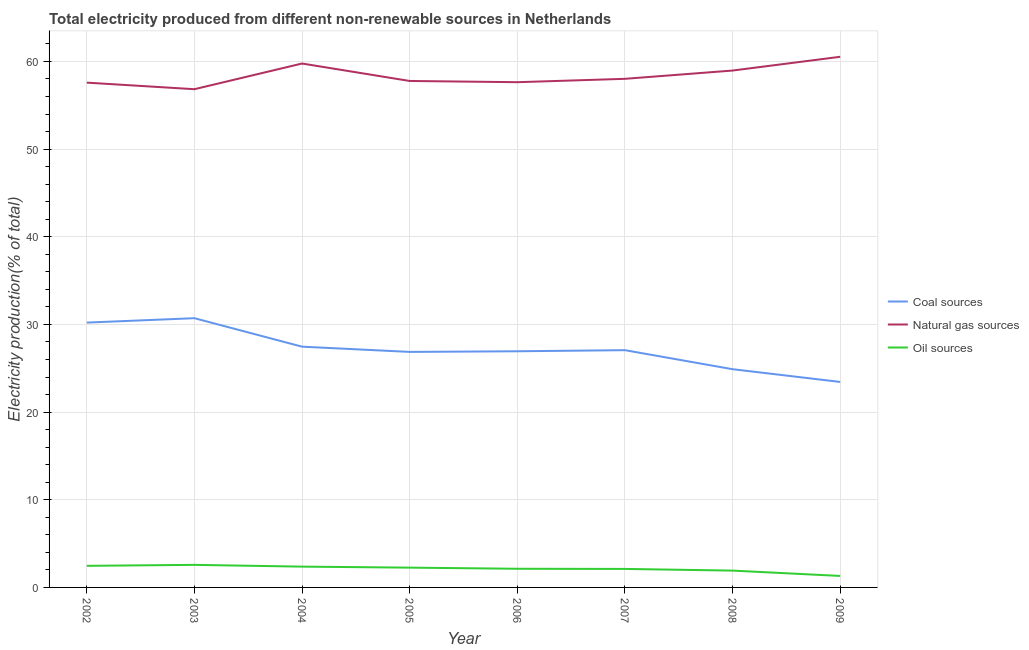How many different coloured lines are there?
Offer a very short reply. 3. What is the percentage of electricity produced by natural gas in 2005?
Your response must be concise. 57.77. Across all years, what is the maximum percentage of electricity produced by coal?
Your answer should be very brief. 30.71. Across all years, what is the minimum percentage of electricity produced by natural gas?
Provide a succinct answer. 56.83. In which year was the percentage of electricity produced by oil sources maximum?
Your answer should be very brief. 2003. What is the total percentage of electricity produced by natural gas in the graph?
Your response must be concise. 467.1. What is the difference between the percentage of electricity produced by natural gas in 2003 and that in 2007?
Keep it short and to the point. -1.18. What is the difference between the percentage of electricity produced by coal in 2006 and the percentage of electricity produced by natural gas in 2003?
Offer a terse response. -29.9. What is the average percentage of electricity produced by coal per year?
Your answer should be compact. 27.2. In the year 2009, what is the difference between the percentage of electricity produced by oil sources and percentage of electricity produced by natural gas?
Offer a very short reply. -59.22. In how many years, is the percentage of electricity produced by oil sources greater than 16 %?
Ensure brevity in your answer.  0. What is the ratio of the percentage of electricity produced by oil sources in 2004 to that in 2005?
Your answer should be very brief. 1.05. Is the percentage of electricity produced by oil sources in 2002 less than that in 2006?
Give a very brief answer. No. What is the difference between the highest and the second highest percentage of electricity produced by coal?
Keep it short and to the point. 0.5. What is the difference between the highest and the lowest percentage of electricity produced by coal?
Ensure brevity in your answer.  7.27. Is it the case that in every year, the sum of the percentage of electricity produced by coal and percentage of electricity produced by natural gas is greater than the percentage of electricity produced by oil sources?
Your response must be concise. Yes. Does the percentage of electricity produced by natural gas monotonically increase over the years?
Your answer should be compact. No. How many lines are there?
Make the answer very short. 3. Does the graph contain grids?
Keep it short and to the point. Yes. How are the legend labels stacked?
Your answer should be compact. Vertical. What is the title of the graph?
Give a very brief answer. Total electricity produced from different non-renewable sources in Netherlands. Does "Spain" appear as one of the legend labels in the graph?
Make the answer very short. No. What is the Electricity production(% of total) in Coal sources in 2002?
Your answer should be very brief. 30.21. What is the Electricity production(% of total) of Natural gas sources in 2002?
Your answer should be compact. 57.58. What is the Electricity production(% of total) in Oil sources in 2002?
Your response must be concise. 2.46. What is the Electricity production(% of total) in Coal sources in 2003?
Ensure brevity in your answer.  30.71. What is the Electricity production(% of total) in Natural gas sources in 2003?
Provide a short and direct response. 56.83. What is the Electricity production(% of total) in Oil sources in 2003?
Provide a short and direct response. 2.57. What is the Electricity production(% of total) of Coal sources in 2004?
Keep it short and to the point. 27.46. What is the Electricity production(% of total) in Natural gas sources in 2004?
Your answer should be very brief. 59.76. What is the Electricity production(% of total) of Oil sources in 2004?
Give a very brief answer. 2.37. What is the Electricity production(% of total) in Coal sources in 2005?
Ensure brevity in your answer.  26.87. What is the Electricity production(% of total) of Natural gas sources in 2005?
Give a very brief answer. 57.77. What is the Electricity production(% of total) of Oil sources in 2005?
Keep it short and to the point. 2.26. What is the Electricity production(% of total) in Coal sources in 2006?
Offer a terse response. 26.94. What is the Electricity production(% of total) in Natural gas sources in 2006?
Ensure brevity in your answer.  57.63. What is the Electricity production(% of total) of Oil sources in 2006?
Keep it short and to the point. 2.13. What is the Electricity production(% of total) in Coal sources in 2007?
Keep it short and to the point. 27.06. What is the Electricity production(% of total) in Natural gas sources in 2007?
Your response must be concise. 58.02. What is the Electricity production(% of total) in Oil sources in 2007?
Your response must be concise. 2.11. What is the Electricity production(% of total) of Coal sources in 2008?
Your answer should be very brief. 24.89. What is the Electricity production(% of total) in Natural gas sources in 2008?
Make the answer very short. 58.96. What is the Electricity production(% of total) in Oil sources in 2008?
Keep it short and to the point. 1.92. What is the Electricity production(% of total) in Coal sources in 2009?
Ensure brevity in your answer.  23.44. What is the Electricity production(% of total) in Natural gas sources in 2009?
Your response must be concise. 60.53. What is the Electricity production(% of total) of Oil sources in 2009?
Offer a very short reply. 1.31. Across all years, what is the maximum Electricity production(% of total) in Coal sources?
Provide a succinct answer. 30.71. Across all years, what is the maximum Electricity production(% of total) in Natural gas sources?
Your response must be concise. 60.53. Across all years, what is the maximum Electricity production(% of total) of Oil sources?
Provide a succinct answer. 2.57. Across all years, what is the minimum Electricity production(% of total) in Coal sources?
Keep it short and to the point. 23.44. Across all years, what is the minimum Electricity production(% of total) of Natural gas sources?
Your answer should be very brief. 56.83. Across all years, what is the minimum Electricity production(% of total) in Oil sources?
Your answer should be very brief. 1.31. What is the total Electricity production(% of total) of Coal sources in the graph?
Make the answer very short. 217.59. What is the total Electricity production(% of total) in Natural gas sources in the graph?
Your answer should be compact. 467.1. What is the total Electricity production(% of total) of Oil sources in the graph?
Provide a short and direct response. 17.14. What is the difference between the Electricity production(% of total) in Coal sources in 2002 and that in 2003?
Give a very brief answer. -0.5. What is the difference between the Electricity production(% of total) of Natural gas sources in 2002 and that in 2003?
Offer a very short reply. 0.75. What is the difference between the Electricity production(% of total) in Oil sources in 2002 and that in 2003?
Keep it short and to the point. -0.11. What is the difference between the Electricity production(% of total) in Coal sources in 2002 and that in 2004?
Make the answer very short. 2.75. What is the difference between the Electricity production(% of total) of Natural gas sources in 2002 and that in 2004?
Your answer should be compact. -2.18. What is the difference between the Electricity production(% of total) of Oil sources in 2002 and that in 2004?
Ensure brevity in your answer.  0.09. What is the difference between the Electricity production(% of total) in Coal sources in 2002 and that in 2005?
Your answer should be compact. 3.34. What is the difference between the Electricity production(% of total) in Natural gas sources in 2002 and that in 2005?
Your answer should be compact. -0.19. What is the difference between the Electricity production(% of total) in Oil sources in 2002 and that in 2005?
Offer a terse response. 0.21. What is the difference between the Electricity production(% of total) in Coal sources in 2002 and that in 2006?
Keep it short and to the point. 3.27. What is the difference between the Electricity production(% of total) of Natural gas sources in 2002 and that in 2006?
Ensure brevity in your answer.  -0.05. What is the difference between the Electricity production(% of total) in Oil sources in 2002 and that in 2006?
Give a very brief answer. 0.33. What is the difference between the Electricity production(% of total) in Coal sources in 2002 and that in 2007?
Your answer should be very brief. 3.15. What is the difference between the Electricity production(% of total) of Natural gas sources in 2002 and that in 2007?
Make the answer very short. -0.44. What is the difference between the Electricity production(% of total) of Oil sources in 2002 and that in 2007?
Keep it short and to the point. 0.35. What is the difference between the Electricity production(% of total) of Coal sources in 2002 and that in 2008?
Your answer should be very brief. 5.32. What is the difference between the Electricity production(% of total) of Natural gas sources in 2002 and that in 2008?
Your response must be concise. -1.38. What is the difference between the Electricity production(% of total) in Oil sources in 2002 and that in 2008?
Provide a short and direct response. 0.54. What is the difference between the Electricity production(% of total) in Coal sources in 2002 and that in 2009?
Your answer should be very brief. 6.77. What is the difference between the Electricity production(% of total) in Natural gas sources in 2002 and that in 2009?
Make the answer very short. -2.95. What is the difference between the Electricity production(% of total) of Oil sources in 2002 and that in 2009?
Provide a short and direct response. 1.15. What is the difference between the Electricity production(% of total) in Coal sources in 2003 and that in 2004?
Offer a terse response. 3.25. What is the difference between the Electricity production(% of total) of Natural gas sources in 2003 and that in 2004?
Provide a short and direct response. -2.93. What is the difference between the Electricity production(% of total) of Oil sources in 2003 and that in 2004?
Your answer should be very brief. 0.2. What is the difference between the Electricity production(% of total) in Coal sources in 2003 and that in 2005?
Your answer should be compact. 3.84. What is the difference between the Electricity production(% of total) of Natural gas sources in 2003 and that in 2005?
Offer a very short reply. -0.94. What is the difference between the Electricity production(% of total) in Oil sources in 2003 and that in 2005?
Keep it short and to the point. 0.32. What is the difference between the Electricity production(% of total) of Coal sources in 2003 and that in 2006?
Give a very brief answer. 3.77. What is the difference between the Electricity production(% of total) in Natural gas sources in 2003 and that in 2006?
Your answer should be compact. -0.8. What is the difference between the Electricity production(% of total) in Oil sources in 2003 and that in 2006?
Provide a succinct answer. 0.45. What is the difference between the Electricity production(% of total) of Coal sources in 2003 and that in 2007?
Make the answer very short. 3.65. What is the difference between the Electricity production(% of total) of Natural gas sources in 2003 and that in 2007?
Offer a terse response. -1.18. What is the difference between the Electricity production(% of total) of Oil sources in 2003 and that in 2007?
Offer a very short reply. 0.46. What is the difference between the Electricity production(% of total) in Coal sources in 2003 and that in 2008?
Offer a very short reply. 5.82. What is the difference between the Electricity production(% of total) in Natural gas sources in 2003 and that in 2008?
Provide a succinct answer. -2.13. What is the difference between the Electricity production(% of total) of Oil sources in 2003 and that in 2008?
Give a very brief answer. 0.66. What is the difference between the Electricity production(% of total) in Coal sources in 2003 and that in 2009?
Keep it short and to the point. 7.27. What is the difference between the Electricity production(% of total) of Natural gas sources in 2003 and that in 2009?
Your answer should be very brief. -3.7. What is the difference between the Electricity production(% of total) in Oil sources in 2003 and that in 2009?
Provide a short and direct response. 1.26. What is the difference between the Electricity production(% of total) in Coal sources in 2004 and that in 2005?
Your answer should be compact. 0.6. What is the difference between the Electricity production(% of total) in Natural gas sources in 2004 and that in 2005?
Offer a very short reply. 1.99. What is the difference between the Electricity production(% of total) of Oil sources in 2004 and that in 2005?
Your response must be concise. 0.12. What is the difference between the Electricity production(% of total) of Coal sources in 2004 and that in 2006?
Provide a succinct answer. 0.52. What is the difference between the Electricity production(% of total) in Natural gas sources in 2004 and that in 2006?
Your response must be concise. 2.13. What is the difference between the Electricity production(% of total) of Oil sources in 2004 and that in 2006?
Offer a very short reply. 0.24. What is the difference between the Electricity production(% of total) of Coal sources in 2004 and that in 2007?
Make the answer very short. 0.4. What is the difference between the Electricity production(% of total) in Natural gas sources in 2004 and that in 2007?
Your response must be concise. 1.74. What is the difference between the Electricity production(% of total) of Oil sources in 2004 and that in 2007?
Provide a short and direct response. 0.26. What is the difference between the Electricity production(% of total) in Coal sources in 2004 and that in 2008?
Provide a short and direct response. 2.57. What is the difference between the Electricity production(% of total) in Natural gas sources in 2004 and that in 2008?
Your answer should be very brief. 0.8. What is the difference between the Electricity production(% of total) of Oil sources in 2004 and that in 2008?
Provide a succinct answer. 0.45. What is the difference between the Electricity production(% of total) of Coal sources in 2004 and that in 2009?
Your response must be concise. 4.02. What is the difference between the Electricity production(% of total) of Natural gas sources in 2004 and that in 2009?
Ensure brevity in your answer.  -0.77. What is the difference between the Electricity production(% of total) in Oil sources in 2004 and that in 2009?
Provide a short and direct response. 1.06. What is the difference between the Electricity production(% of total) of Coal sources in 2005 and that in 2006?
Provide a succinct answer. -0.07. What is the difference between the Electricity production(% of total) in Natural gas sources in 2005 and that in 2006?
Provide a short and direct response. 0.14. What is the difference between the Electricity production(% of total) in Oil sources in 2005 and that in 2006?
Offer a terse response. 0.13. What is the difference between the Electricity production(% of total) of Coal sources in 2005 and that in 2007?
Ensure brevity in your answer.  -0.2. What is the difference between the Electricity production(% of total) of Natural gas sources in 2005 and that in 2007?
Provide a short and direct response. -0.24. What is the difference between the Electricity production(% of total) of Oil sources in 2005 and that in 2007?
Ensure brevity in your answer.  0.15. What is the difference between the Electricity production(% of total) of Coal sources in 2005 and that in 2008?
Your response must be concise. 1.97. What is the difference between the Electricity production(% of total) of Natural gas sources in 2005 and that in 2008?
Your answer should be very brief. -1.19. What is the difference between the Electricity production(% of total) of Oil sources in 2005 and that in 2008?
Your answer should be very brief. 0.34. What is the difference between the Electricity production(% of total) in Coal sources in 2005 and that in 2009?
Your answer should be very brief. 3.43. What is the difference between the Electricity production(% of total) in Natural gas sources in 2005 and that in 2009?
Provide a succinct answer. -2.76. What is the difference between the Electricity production(% of total) in Oil sources in 2005 and that in 2009?
Your answer should be compact. 0.95. What is the difference between the Electricity production(% of total) in Coal sources in 2006 and that in 2007?
Your answer should be very brief. -0.13. What is the difference between the Electricity production(% of total) of Natural gas sources in 2006 and that in 2007?
Provide a short and direct response. -0.38. What is the difference between the Electricity production(% of total) of Oil sources in 2006 and that in 2007?
Ensure brevity in your answer.  0.02. What is the difference between the Electricity production(% of total) in Coal sources in 2006 and that in 2008?
Give a very brief answer. 2.04. What is the difference between the Electricity production(% of total) in Natural gas sources in 2006 and that in 2008?
Keep it short and to the point. -1.33. What is the difference between the Electricity production(% of total) in Oil sources in 2006 and that in 2008?
Provide a short and direct response. 0.21. What is the difference between the Electricity production(% of total) in Coal sources in 2006 and that in 2009?
Offer a very short reply. 3.5. What is the difference between the Electricity production(% of total) of Natural gas sources in 2006 and that in 2009?
Your response must be concise. -2.9. What is the difference between the Electricity production(% of total) in Oil sources in 2006 and that in 2009?
Make the answer very short. 0.82. What is the difference between the Electricity production(% of total) in Coal sources in 2007 and that in 2008?
Ensure brevity in your answer.  2.17. What is the difference between the Electricity production(% of total) in Natural gas sources in 2007 and that in 2008?
Offer a very short reply. -0.94. What is the difference between the Electricity production(% of total) in Oil sources in 2007 and that in 2008?
Your answer should be very brief. 0.19. What is the difference between the Electricity production(% of total) in Coal sources in 2007 and that in 2009?
Give a very brief answer. 3.62. What is the difference between the Electricity production(% of total) of Natural gas sources in 2007 and that in 2009?
Ensure brevity in your answer.  -2.51. What is the difference between the Electricity production(% of total) of Oil sources in 2007 and that in 2009?
Offer a terse response. 0.8. What is the difference between the Electricity production(% of total) of Coal sources in 2008 and that in 2009?
Your answer should be very brief. 1.45. What is the difference between the Electricity production(% of total) of Natural gas sources in 2008 and that in 2009?
Give a very brief answer. -1.57. What is the difference between the Electricity production(% of total) in Oil sources in 2008 and that in 2009?
Provide a short and direct response. 0.61. What is the difference between the Electricity production(% of total) in Coal sources in 2002 and the Electricity production(% of total) in Natural gas sources in 2003?
Your response must be concise. -26.62. What is the difference between the Electricity production(% of total) of Coal sources in 2002 and the Electricity production(% of total) of Oil sources in 2003?
Offer a terse response. 27.64. What is the difference between the Electricity production(% of total) in Natural gas sources in 2002 and the Electricity production(% of total) in Oil sources in 2003?
Make the answer very short. 55.01. What is the difference between the Electricity production(% of total) of Coal sources in 2002 and the Electricity production(% of total) of Natural gas sources in 2004?
Provide a short and direct response. -29.55. What is the difference between the Electricity production(% of total) of Coal sources in 2002 and the Electricity production(% of total) of Oil sources in 2004?
Make the answer very short. 27.84. What is the difference between the Electricity production(% of total) in Natural gas sources in 2002 and the Electricity production(% of total) in Oil sources in 2004?
Your response must be concise. 55.21. What is the difference between the Electricity production(% of total) of Coal sources in 2002 and the Electricity production(% of total) of Natural gas sources in 2005?
Provide a succinct answer. -27.56. What is the difference between the Electricity production(% of total) of Coal sources in 2002 and the Electricity production(% of total) of Oil sources in 2005?
Ensure brevity in your answer.  27.95. What is the difference between the Electricity production(% of total) of Natural gas sources in 2002 and the Electricity production(% of total) of Oil sources in 2005?
Your answer should be very brief. 55.32. What is the difference between the Electricity production(% of total) in Coal sources in 2002 and the Electricity production(% of total) in Natural gas sources in 2006?
Offer a terse response. -27.42. What is the difference between the Electricity production(% of total) in Coal sources in 2002 and the Electricity production(% of total) in Oil sources in 2006?
Provide a short and direct response. 28.08. What is the difference between the Electricity production(% of total) of Natural gas sources in 2002 and the Electricity production(% of total) of Oil sources in 2006?
Your answer should be compact. 55.45. What is the difference between the Electricity production(% of total) of Coal sources in 2002 and the Electricity production(% of total) of Natural gas sources in 2007?
Make the answer very short. -27.81. What is the difference between the Electricity production(% of total) of Coal sources in 2002 and the Electricity production(% of total) of Oil sources in 2007?
Your answer should be compact. 28.1. What is the difference between the Electricity production(% of total) of Natural gas sources in 2002 and the Electricity production(% of total) of Oil sources in 2007?
Provide a short and direct response. 55.47. What is the difference between the Electricity production(% of total) of Coal sources in 2002 and the Electricity production(% of total) of Natural gas sources in 2008?
Offer a terse response. -28.75. What is the difference between the Electricity production(% of total) of Coal sources in 2002 and the Electricity production(% of total) of Oil sources in 2008?
Offer a terse response. 28.29. What is the difference between the Electricity production(% of total) of Natural gas sources in 2002 and the Electricity production(% of total) of Oil sources in 2008?
Your answer should be very brief. 55.66. What is the difference between the Electricity production(% of total) in Coal sources in 2002 and the Electricity production(% of total) in Natural gas sources in 2009?
Keep it short and to the point. -30.32. What is the difference between the Electricity production(% of total) of Coal sources in 2002 and the Electricity production(% of total) of Oil sources in 2009?
Make the answer very short. 28.9. What is the difference between the Electricity production(% of total) of Natural gas sources in 2002 and the Electricity production(% of total) of Oil sources in 2009?
Offer a terse response. 56.27. What is the difference between the Electricity production(% of total) of Coal sources in 2003 and the Electricity production(% of total) of Natural gas sources in 2004?
Make the answer very short. -29.05. What is the difference between the Electricity production(% of total) of Coal sources in 2003 and the Electricity production(% of total) of Oil sources in 2004?
Give a very brief answer. 28.34. What is the difference between the Electricity production(% of total) in Natural gas sources in 2003 and the Electricity production(% of total) in Oil sources in 2004?
Your answer should be compact. 54.46. What is the difference between the Electricity production(% of total) of Coal sources in 2003 and the Electricity production(% of total) of Natural gas sources in 2005?
Offer a terse response. -27.06. What is the difference between the Electricity production(% of total) in Coal sources in 2003 and the Electricity production(% of total) in Oil sources in 2005?
Ensure brevity in your answer.  28.45. What is the difference between the Electricity production(% of total) in Natural gas sources in 2003 and the Electricity production(% of total) in Oil sources in 2005?
Provide a succinct answer. 54.58. What is the difference between the Electricity production(% of total) in Coal sources in 2003 and the Electricity production(% of total) in Natural gas sources in 2006?
Your answer should be compact. -26.92. What is the difference between the Electricity production(% of total) in Coal sources in 2003 and the Electricity production(% of total) in Oil sources in 2006?
Provide a short and direct response. 28.58. What is the difference between the Electricity production(% of total) of Natural gas sources in 2003 and the Electricity production(% of total) of Oil sources in 2006?
Offer a very short reply. 54.7. What is the difference between the Electricity production(% of total) in Coal sources in 2003 and the Electricity production(% of total) in Natural gas sources in 2007?
Offer a terse response. -27.31. What is the difference between the Electricity production(% of total) of Coal sources in 2003 and the Electricity production(% of total) of Oil sources in 2007?
Keep it short and to the point. 28.6. What is the difference between the Electricity production(% of total) of Natural gas sources in 2003 and the Electricity production(% of total) of Oil sources in 2007?
Give a very brief answer. 54.72. What is the difference between the Electricity production(% of total) in Coal sources in 2003 and the Electricity production(% of total) in Natural gas sources in 2008?
Provide a short and direct response. -28.25. What is the difference between the Electricity production(% of total) of Coal sources in 2003 and the Electricity production(% of total) of Oil sources in 2008?
Your answer should be very brief. 28.79. What is the difference between the Electricity production(% of total) of Natural gas sources in 2003 and the Electricity production(% of total) of Oil sources in 2008?
Make the answer very short. 54.92. What is the difference between the Electricity production(% of total) in Coal sources in 2003 and the Electricity production(% of total) in Natural gas sources in 2009?
Make the answer very short. -29.82. What is the difference between the Electricity production(% of total) in Coal sources in 2003 and the Electricity production(% of total) in Oil sources in 2009?
Offer a very short reply. 29.4. What is the difference between the Electricity production(% of total) in Natural gas sources in 2003 and the Electricity production(% of total) in Oil sources in 2009?
Keep it short and to the point. 55.52. What is the difference between the Electricity production(% of total) of Coal sources in 2004 and the Electricity production(% of total) of Natural gas sources in 2005?
Offer a terse response. -30.31. What is the difference between the Electricity production(% of total) in Coal sources in 2004 and the Electricity production(% of total) in Oil sources in 2005?
Ensure brevity in your answer.  25.21. What is the difference between the Electricity production(% of total) of Natural gas sources in 2004 and the Electricity production(% of total) of Oil sources in 2005?
Keep it short and to the point. 57.51. What is the difference between the Electricity production(% of total) of Coal sources in 2004 and the Electricity production(% of total) of Natural gas sources in 2006?
Keep it short and to the point. -30.17. What is the difference between the Electricity production(% of total) in Coal sources in 2004 and the Electricity production(% of total) in Oil sources in 2006?
Make the answer very short. 25.33. What is the difference between the Electricity production(% of total) of Natural gas sources in 2004 and the Electricity production(% of total) of Oil sources in 2006?
Your answer should be compact. 57.63. What is the difference between the Electricity production(% of total) in Coal sources in 2004 and the Electricity production(% of total) in Natural gas sources in 2007?
Offer a very short reply. -30.56. What is the difference between the Electricity production(% of total) of Coal sources in 2004 and the Electricity production(% of total) of Oil sources in 2007?
Your answer should be compact. 25.35. What is the difference between the Electricity production(% of total) in Natural gas sources in 2004 and the Electricity production(% of total) in Oil sources in 2007?
Provide a succinct answer. 57.65. What is the difference between the Electricity production(% of total) in Coal sources in 2004 and the Electricity production(% of total) in Natural gas sources in 2008?
Ensure brevity in your answer.  -31.5. What is the difference between the Electricity production(% of total) of Coal sources in 2004 and the Electricity production(% of total) of Oil sources in 2008?
Make the answer very short. 25.54. What is the difference between the Electricity production(% of total) of Natural gas sources in 2004 and the Electricity production(% of total) of Oil sources in 2008?
Offer a terse response. 57.84. What is the difference between the Electricity production(% of total) of Coal sources in 2004 and the Electricity production(% of total) of Natural gas sources in 2009?
Offer a terse response. -33.07. What is the difference between the Electricity production(% of total) in Coal sources in 2004 and the Electricity production(% of total) in Oil sources in 2009?
Provide a short and direct response. 26.15. What is the difference between the Electricity production(% of total) of Natural gas sources in 2004 and the Electricity production(% of total) of Oil sources in 2009?
Your answer should be compact. 58.45. What is the difference between the Electricity production(% of total) in Coal sources in 2005 and the Electricity production(% of total) in Natural gas sources in 2006?
Give a very brief answer. -30.77. What is the difference between the Electricity production(% of total) of Coal sources in 2005 and the Electricity production(% of total) of Oil sources in 2006?
Offer a terse response. 24.74. What is the difference between the Electricity production(% of total) in Natural gas sources in 2005 and the Electricity production(% of total) in Oil sources in 2006?
Your answer should be very brief. 55.64. What is the difference between the Electricity production(% of total) of Coal sources in 2005 and the Electricity production(% of total) of Natural gas sources in 2007?
Your answer should be compact. -31.15. What is the difference between the Electricity production(% of total) in Coal sources in 2005 and the Electricity production(% of total) in Oil sources in 2007?
Provide a short and direct response. 24.76. What is the difference between the Electricity production(% of total) in Natural gas sources in 2005 and the Electricity production(% of total) in Oil sources in 2007?
Provide a short and direct response. 55.66. What is the difference between the Electricity production(% of total) in Coal sources in 2005 and the Electricity production(% of total) in Natural gas sources in 2008?
Give a very brief answer. -32.1. What is the difference between the Electricity production(% of total) in Coal sources in 2005 and the Electricity production(% of total) in Oil sources in 2008?
Offer a very short reply. 24.95. What is the difference between the Electricity production(% of total) of Natural gas sources in 2005 and the Electricity production(% of total) of Oil sources in 2008?
Provide a short and direct response. 55.86. What is the difference between the Electricity production(% of total) of Coal sources in 2005 and the Electricity production(% of total) of Natural gas sources in 2009?
Keep it short and to the point. -33.66. What is the difference between the Electricity production(% of total) of Coal sources in 2005 and the Electricity production(% of total) of Oil sources in 2009?
Your response must be concise. 25.56. What is the difference between the Electricity production(% of total) in Natural gas sources in 2005 and the Electricity production(% of total) in Oil sources in 2009?
Offer a terse response. 56.46. What is the difference between the Electricity production(% of total) in Coal sources in 2006 and the Electricity production(% of total) in Natural gas sources in 2007?
Offer a very short reply. -31.08. What is the difference between the Electricity production(% of total) in Coal sources in 2006 and the Electricity production(% of total) in Oil sources in 2007?
Make the answer very short. 24.83. What is the difference between the Electricity production(% of total) in Natural gas sources in 2006 and the Electricity production(% of total) in Oil sources in 2007?
Your response must be concise. 55.52. What is the difference between the Electricity production(% of total) in Coal sources in 2006 and the Electricity production(% of total) in Natural gas sources in 2008?
Ensure brevity in your answer.  -32.02. What is the difference between the Electricity production(% of total) of Coal sources in 2006 and the Electricity production(% of total) of Oil sources in 2008?
Offer a very short reply. 25.02. What is the difference between the Electricity production(% of total) in Natural gas sources in 2006 and the Electricity production(% of total) in Oil sources in 2008?
Offer a terse response. 55.71. What is the difference between the Electricity production(% of total) of Coal sources in 2006 and the Electricity production(% of total) of Natural gas sources in 2009?
Provide a short and direct response. -33.59. What is the difference between the Electricity production(% of total) in Coal sources in 2006 and the Electricity production(% of total) in Oil sources in 2009?
Provide a short and direct response. 25.63. What is the difference between the Electricity production(% of total) of Natural gas sources in 2006 and the Electricity production(% of total) of Oil sources in 2009?
Make the answer very short. 56.32. What is the difference between the Electricity production(% of total) of Coal sources in 2007 and the Electricity production(% of total) of Natural gas sources in 2008?
Offer a very short reply. -31.9. What is the difference between the Electricity production(% of total) in Coal sources in 2007 and the Electricity production(% of total) in Oil sources in 2008?
Keep it short and to the point. 25.15. What is the difference between the Electricity production(% of total) of Natural gas sources in 2007 and the Electricity production(% of total) of Oil sources in 2008?
Your answer should be compact. 56.1. What is the difference between the Electricity production(% of total) in Coal sources in 2007 and the Electricity production(% of total) in Natural gas sources in 2009?
Keep it short and to the point. -33.47. What is the difference between the Electricity production(% of total) in Coal sources in 2007 and the Electricity production(% of total) in Oil sources in 2009?
Your answer should be compact. 25.75. What is the difference between the Electricity production(% of total) of Natural gas sources in 2007 and the Electricity production(% of total) of Oil sources in 2009?
Offer a very short reply. 56.71. What is the difference between the Electricity production(% of total) in Coal sources in 2008 and the Electricity production(% of total) in Natural gas sources in 2009?
Offer a terse response. -35.64. What is the difference between the Electricity production(% of total) of Coal sources in 2008 and the Electricity production(% of total) of Oil sources in 2009?
Ensure brevity in your answer.  23.58. What is the difference between the Electricity production(% of total) of Natural gas sources in 2008 and the Electricity production(% of total) of Oil sources in 2009?
Keep it short and to the point. 57.65. What is the average Electricity production(% of total) of Coal sources per year?
Your response must be concise. 27.2. What is the average Electricity production(% of total) in Natural gas sources per year?
Make the answer very short. 58.39. What is the average Electricity production(% of total) in Oil sources per year?
Your response must be concise. 2.14. In the year 2002, what is the difference between the Electricity production(% of total) in Coal sources and Electricity production(% of total) in Natural gas sources?
Provide a short and direct response. -27.37. In the year 2002, what is the difference between the Electricity production(% of total) in Coal sources and Electricity production(% of total) in Oil sources?
Keep it short and to the point. 27.75. In the year 2002, what is the difference between the Electricity production(% of total) of Natural gas sources and Electricity production(% of total) of Oil sources?
Provide a short and direct response. 55.12. In the year 2003, what is the difference between the Electricity production(% of total) of Coal sources and Electricity production(% of total) of Natural gas sources?
Ensure brevity in your answer.  -26.12. In the year 2003, what is the difference between the Electricity production(% of total) of Coal sources and Electricity production(% of total) of Oil sources?
Offer a terse response. 28.14. In the year 2003, what is the difference between the Electricity production(% of total) of Natural gas sources and Electricity production(% of total) of Oil sources?
Make the answer very short. 54.26. In the year 2004, what is the difference between the Electricity production(% of total) of Coal sources and Electricity production(% of total) of Natural gas sources?
Make the answer very short. -32.3. In the year 2004, what is the difference between the Electricity production(% of total) of Coal sources and Electricity production(% of total) of Oil sources?
Give a very brief answer. 25.09. In the year 2004, what is the difference between the Electricity production(% of total) in Natural gas sources and Electricity production(% of total) in Oil sources?
Your answer should be very brief. 57.39. In the year 2005, what is the difference between the Electricity production(% of total) in Coal sources and Electricity production(% of total) in Natural gas sources?
Make the answer very short. -30.91. In the year 2005, what is the difference between the Electricity production(% of total) in Coal sources and Electricity production(% of total) in Oil sources?
Your answer should be compact. 24.61. In the year 2005, what is the difference between the Electricity production(% of total) in Natural gas sources and Electricity production(% of total) in Oil sources?
Offer a very short reply. 55.52. In the year 2006, what is the difference between the Electricity production(% of total) of Coal sources and Electricity production(% of total) of Natural gas sources?
Your response must be concise. -30.69. In the year 2006, what is the difference between the Electricity production(% of total) in Coal sources and Electricity production(% of total) in Oil sources?
Your response must be concise. 24.81. In the year 2006, what is the difference between the Electricity production(% of total) in Natural gas sources and Electricity production(% of total) in Oil sources?
Ensure brevity in your answer.  55.5. In the year 2007, what is the difference between the Electricity production(% of total) in Coal sources and Electricity production(% of total) in Natural gas sources?
Your answer should be compact. -30.95. In the year 2007, what is the difference between the Electricity production(% of total) in Coal sources and Electricity production(% of total) in Oil sources?
Give a very brief answer. 24.95. In the year 2007, what is the difference between the Electricity production(% of total) in Natural gas sources and Electricity production(% of total) in Oil sources?
Provide a short and direct response. 55.91. In the year 2008, what is the difference between the Electricity production(% of total) of Coal sources and Electricity production(% of total) of Natural gas sources?
Keep it short and to the point. -34.07. In the year 2008, what is the difference between the Electricity production(% of total) in Coal sources and Electricity production(% of total) in Oil sources?
Give a very brief answer. 22.98. In the year 2008, what is the difference between the Electricity production(% of total) in Natural gas sources and Electricity production(% of total) in Oil sources?
Keep it short and to the point. 57.04. In the year 2009, what is the difference between the Electricity production(% of total) in Coal sources and Electricity production(% of total) in Natural gas sources?
Offer a terse response. -37.09. In the year 2009, what is the difference between the Electricity production(% of total) in Coal sources and Electricity production(% of total) in Oil sources?
Provide a short and direct response. 22.13. In the year 2009, what is the difference between the Electricity production(% of total) in Natural gas sources and Electricity production(% of total) in Oil sources?
Your response must be concise. 59.22. What is the ratio of the Electricity production(% of total) of Coal sources in 2002 to that in 2003?
Provide a short and direct response. 0.98. What is the ratio of the Electricity production(% of total) in Natural gas sources in 2002 to that in 2003?
Your answer should be compact. 1.01. What is the ratio of the Electricity production(% of total) of Oil sources in 2002 to that in 2003?
Provide a succinct answer. 0.96. What is the ratio of the Electricity production(% of total) in Coal sources in 2002 to that in 2004?
Provide a short and direct response. 1.1. What is the ratio of the Electricity production(% of total) of Natural gas sources in 2002 to that in 2004?
Your answer should be very brief. 0.96. What is the ratio of the Electricity production(% of total) of Oil sources in 2002 to that in 2004?
Your answer should be compact. 1.04. What is the ratio of the Electricity production(% of total) in Coal sources in 2002 to that in 2005?
Provide a succinct answer. 1.12. What is the ratio of the Electricity production(% of total) in Natural gas sources in 2002 to that in 2005?
Ensure brevity in your answer.  1. What is the ratio of the Electricity production(% of total) of Oil sources in 2002 to that in 2005?
Your answer should be very brief. 1.09. What is the ratio of the Electricity production(% of total) of Coal sources in 2002 to that in 2006?
Offer a very short reply. 1.12. What is the ratio of the Electricity production(% of total) of Natural gas sources in 2002 to that in 2006?
Your answer should be compact. 1. What is the ratio of the Electricity production(% of total) in Oil sources in 2002 to that in 2006?
Your response must be concise. 1.16. What is the ratio of the Electricity production(% of total) of Coal sources in 2002 to that in 2007?
Provide a short and direct response. 1.12. What is the ratio of the Electricity production(% of total) in Natural gas sources in 2002 to that in 2007?
Ensure brevity in your answer.  0.99. What is the ratio of the Electricity production(% of total) of Oil sources in 2002 to that in 2007?
Your response must be concise. 1.17. What is the ratio of the Electricity production(% of total) in Coal sources in 2002 to that in 2008?
Keep it short and to the point. 1.21. What is the ratio of the Electricity production(% of total) in Natural gas sources in 2002 to that in 2008?
Offer a terse response. 0.98. What is the ratio of the Electricity production(% of total) in Oil sources in 2002 to that in 2008?
Provide a succinct answer. 1.28. What is the ratio of the Electricity production(% of total) of Coal sources in 2002 to that in 2009?
Offer a terse response. 1.29. What is the ratio of the Electricity production(% of total) of Natural gas sources in 2002 to that in 2009?
Your answer should be very brief. 0.95. What is the ratio of the Electricity production(% of total) of Oil sources in 2002 to that in 2009?
Offer a very short reply. 1.88. What is the ratio of the Electricity production(% of total) in Coal sources in 2003 to that in 2004?
Offer a terse response. 1.12. What is the ratio of the Electricity production(% of total) of Natural gas sources in 2003 to that in 2004?
Provide a succinct answer. 0.95. What is the ratio of the Electricity production(% of total) in Oil sources in 2003 to that in 2004?
Provide a short and direct response. 1.08. What is the ratio of the Electricity production(% of total) in Coal sources in 2003 to that in 2005?
Your answer should be very brief. 1.14. What is the ratio of the Electricity production(% of total) in Natural gas sources in 2003 to that in 2005?
Ensure brevity in your answer.  0.98. What is the ratio of the Electricity production(% of total) in Oil sources in 2003 to that in 2005?
Make the answer very short. 1.14. What is the ratio of the Electricity production(% of total) of Coal sources in 2003 to that in 2006?
Your response must be concise. 1.14. What is the ratio of the Electricity production(% of total) in Natural gas sources in 2003 to that in 2006?
Offer a terse response. 0.99. What is the ratio of the Electricity production(% of total) of Oil sources in 2003 to that in 2006?
Give a very brief answer. 1.21. What is the ratio of the Electricity production(% of total) in Coal sources in 2003 to that in 2007?
Make the answer very short. 1.13. What is the ratio of the Electricity production(% of total) of Natural gas sources in 2003 to that in 2007?
Your response must be concise. 0.98. What is the ratio of the Electricity production(% of total) of Oil sources in 2003 to that in 2007?
Your response must be concise. 1.22. What is the ratio of the Electricity production(% of total) in Coal sources in 2003 to that in 2008?
Your response must be concise. 1.23. What is the ratio of the Electricity production(% of total) in Natural gas sources in 2003 to that in 2008?
Provide a succinct answer. 0.96. What is the ratio of the Electricity production(% of total) in Oil sources in 2003 to that in 2008?
Your answer should be very brief. 1.34. What is the ratio of the Electricity production(% of total) of Coal sources in 2003 to that in 2009?
Ensure brevity in your answer.  1.31. What is the ratio of the Electricity production(% of total) of Natural gas sources in 2003 to that in 2009?
Ensure brevity in your answer.  0.94. What is the ratio of the Electricity production(% of total) of Oil sources in 2003 to that in 2009?
Provide a succinct answer. 1.97. What is the ratio of the Electricity production(% of total) of Coal sources in 2004 to that in 2005?
Your answer should be compact. 1.02. What is the ratio of the Electricity production(% of total) in Natural gas sources in 2004 to that in 2005?
Keep it short and to the point. 1.03. What is the ratio of the Electricity production(% of total) in Oil sources in 2004 to that in 2005?
Offer a terse response. 1.05. What is the ratio of the Electricity production(% of total) in Coal sources in 2004 to that in 2006?
Your answer should be compact. 1.02. What is the ratio of the Electricity production(% of total) of Oil sources in 2004 to that in 2006?
Provide a short and direct response. 1.11. What is the ratio of the Electricity production(% of total) in Coal sources in 2004 to that in 2007?
Ensure brevity in your answer.  1.01. What is the ratio of the Electricity production(% of total) of Natural gas sources in 2004 to that in 2007?
Give a very brief answer. 1.03. What is the ratio of the Electricity production(% of total) of Oil sources in 2004 to that in 2007?
Your answer should be compact. 1.12. What is the ratio of the Electricity production(% of total) of Coal sources in 2004 to that in 2008?
Provide a succinct answer. 1.1. What is the ratio of the Electricity production(% of total) of Natural gas sources in 2004 to that in 2008?
Ensure brevity in your answer.  1.01. What is the ratio of the Electricity production(% of total) of Oil sources in 2004 to that in 2008?
Give a very brief answer. 1.24. What is the ratio of the Electricity production(% of total) of Coal sources in 2004 to that in 2009?
Your answer should be very brief. 1.17. What is the ratio of the Electricity production(% of total) of Natural gas sources in 2004 to that in 2009?
Ensure brevity in your answer.  0.99. What is the ratio of the Electricity production(% of total) in Oil sources in 2004 to that in 2009?
Provide a short and direct response. 1.81. What is the ratio of the Electricity production(% of total) of Coal sources in 2005 to that in 2006?
Ensure brevity in your answer.  1. What is the ratio of the Electricity production(% of total) in Oil sources in 2005 to that in 2006?
Make the answer very short. 1.06. What is the ratio of the Electricity production(% of total) in Oil sources in 2005 to that in 2007?
Your answer should be compact. 1.07. What is the ratio of the Electricity production(% of total) in Coal sources in 2005 to that in 2008?
Make the answer very short. 1.08. What is the ratio of the Electricity production(% of total) of Natural gas sources in 2005 to that in 2008?
Make the answer very short. 0.98. What is the ratio of the Electricity production(% of total) of Oil sources in 2005 to that in 2008?
Offer a terse response. 1.18. What is the ratio of the Electricity production(% of total) of Coal sources in 2005 to that in 2009?
Provide a short and direct response. 1.15. What is the ratio of the Electricity production(% of total) of Natural gas sources in 2005 to that in 2009?
Keep it short and to the point. 0.95. What is the ratio of the Electricity production(% of total) of Oil sources in 2005 to that in 2009?
Provide a short and direct response. 1.72. What is the ratio of the Electricity production(% of total) in Coal sources in 2006 to that in 2007?
Provide a succinct answer. 1. What is the ratio of the Electricity production(% of total) in Oil sources in 2006 to that in 2007?
Provide a short and direct response. 1.01. What is the ratio of the Electricity production(% of total) of Coal sources in 2006 to that in 2008?
Give a very brief answer. 1.08. What is the ratio of the Electricity production(% of total) of Natural gas sources in 2006 to that in 2008?
Keep it short and to the point. 0.98. What is the ratio of the Electricity production(% of total) of Oil sources in 2006 to that in 2008?
Keep it short and to the point. 1.11. What is the ratio of the Electricity production(% of total) in Coal sources in 2006 to that in 2009?
Keep it short and to the point. 1.15. What is the ratio of the Electricity production(% of total) in Natural gas sources in 2006 to that in 2009?
Offer a very short reply. 0.95. What is the ratio of the Electricity production(% of total) of Oil sources in 2006 to that in 2009?
Provide a succinct answer. 1.63. What is the ratio of the Electricity production(% of total) in Coal sources in 2007 to that in 2008?
Your answer should be very brief. 1.09. What is the ratio of the Electricity production(% of total) in Oil sources in 2007 to that in 2008?
Your answer should be compact. 1.1. What is the ratio of the Electricity production(% of total) in Coal sources in 2007 to that in 2009?
Ensure brevity in your answer.  1.15. What is the ratio of the Electricity production(% of total) in Natural gas sources in 2007 to that in 2009?
Ensure brevity in your answer.  0.96. What is the ratio of the Electricity production(% of total) of Oil sources in 2007 to that in 2009?
Offer a very short reply. 1.61. What is the ratio of the Electricity production(% of total) of Coal sources in 2008 to that in 2009?
Your answer should be compact. 1.06. What is the ratio of the Electricity production(% of total) of Natural gas sources in 2008 to that in 2009?
Make the answer very short. 0.97. What is the ratio of the Electricity production(% of total) of Oil sources in 2008 to that in 2009?
Provide a succinct answer. 1.46. What is the difference between the highest and the second highest Electricity production(% of total) of Coal sources?
Your answer should be compact. 0.5. What is the difference between the highest and the second highest Electricity production(% of total) of Natural gas sources?
Make the answer very short. 0.77. What is the difference between the highest and the second highest Electricity production(% of total) in Oil sources?
Provide a short and direct response. 0.11. What is the difference between the highest and the lowest Electricity production(% of total) of Coal sources?
Provide a succinct answer. 7.27. What is the difference between the highest and the lowest Electricity production(% of total) of Natural gas sources?
Keep it short and to the point. 3.7. What is the difference between the highest and the lowest Electricity production(% of total) in Oil sources?
Your response must be concise. 1.26. 